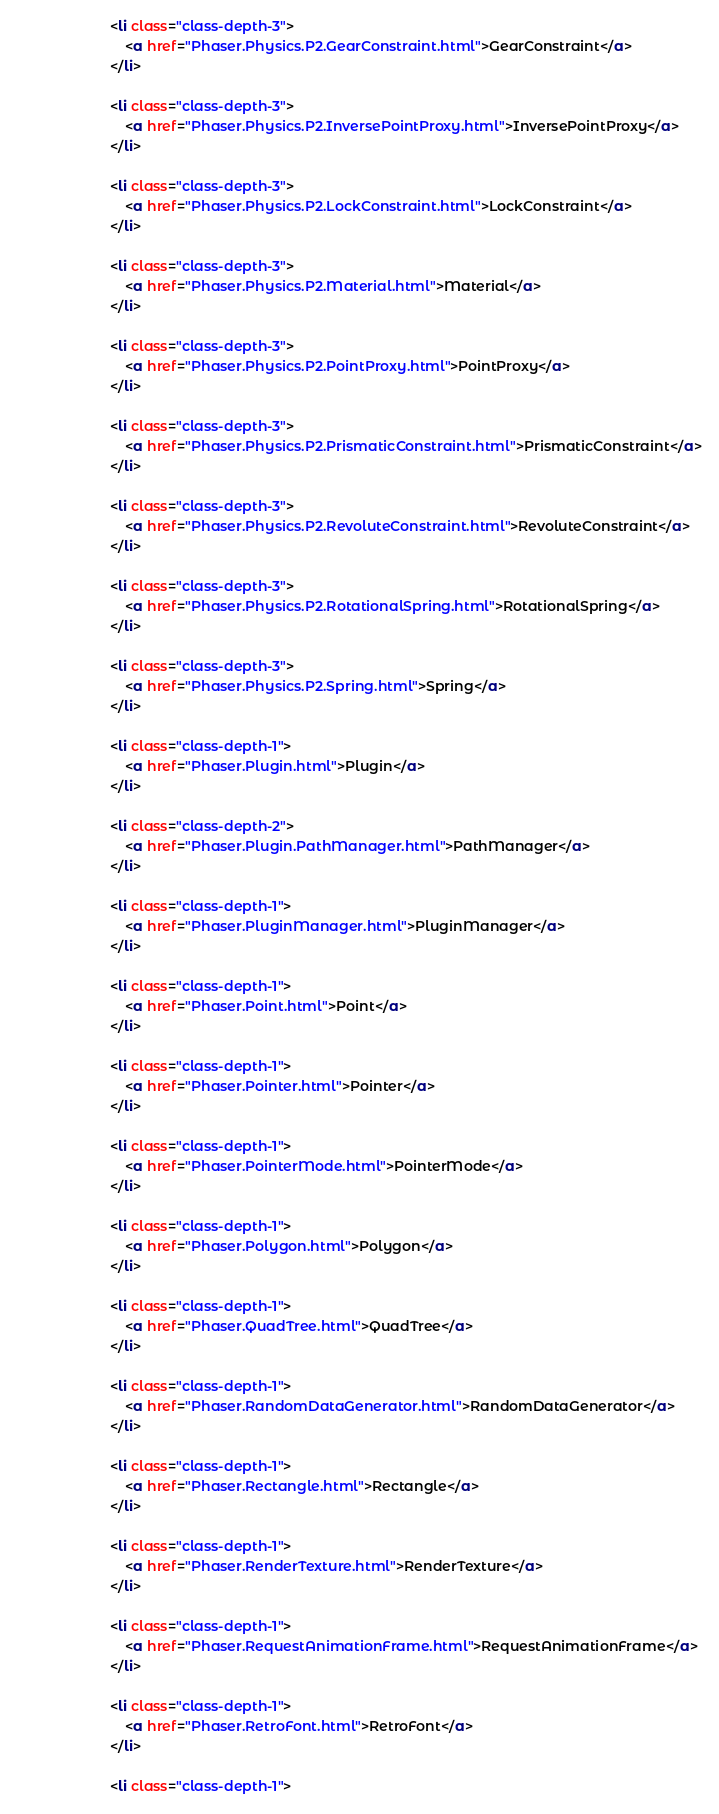Convert code to text. <code><loc_0><loc_0><loc_500><loc_500><_HTML_>						<li class="class-depth-3">
							<a href="Phaser.Physics.P2.GearConstraint.html">GearConstraint</a>
						</li>
						
						<li class="class-depth-3">
							<a href="Phaser.Physics.P2.InversePointProxy.html">InversePointProxy</a>
						</li>
						
						<li class="class-depth-3">
							<a href="Phaser.Physics.P2.LockConstraint.html">LockConstraint</a>
						</li>
						
						<li class="class-depth-3">
							<a href="Phaser.Physics.P2.Material.html">Material</a>
						</li>
						
						<li class="class-depth-3">
							<a href="Phaser.Physics.P2.PointProxy.html">PointProxy</a>
						</li>
						
						<li class="class-depth-3">
							<a href="Phaser.Physics.P2.PrismaticConstraint.html">PrismaticConstraint</a>
						</li>
						
						<li class="class-depth-3">
							<a href="Phaser.Physics.P2.RevoluteConstraint.html">RevoluteConstraint</a>
						</li>
						
						<li class="class-depth-3">
							<a href="Phaser.Physics.P2.RotationalSpring.html">RotationalSpring</a>
						</li>
						
						<li class="class-depth-3">
							<a href="Phaser.Physics.P2.Spring.html">Spring</a>
						</li>
						
						<li class="class-depth-1">
							<a href="Phaser.Plugin.html">Plugin</a>
						</li>
						
						<li class="class-depth-2">
							<a href="Phaser.Plugin.PathManager.html">PathManager</a>
						</li>
						
						<li class="class-depth-1">
							<a href="Phaser.PluginManager.html">PluginManager</a>
						</li>
						
						<li class="class-depth-1">
							<a href="Phaser.Point.html">Point</a>
						</li>
						
						<li class="class-depth-1">
							<a href="Phaser.Pointer.html">Pointer</a>
						</li>
						
						<li class="class-depth-1">
							<a href="Phaser.PointerMode.html">PointerMode</a>
						</li>
						
						<li class="class-depth-1">
							<a href="Phaser.Polygon.html">Polygon</a>
						</li>
						
						<li class="class-depth-1">
							<a href="Phaser.QuadTree.html">QuadTree</a>
						</li>
						
						<li class="class-depth-1">
							<a href="Phaser.RandomDataGenerator.html">RandomDataGenerator</a>
						</li>
						
						<li class="class-depth-1">
							<a href="Phaser.Rectangle.html">Rectangle</a>
						</li>
						
						<li class="class-depth-1">
							<a href="Phaser.RenderTexture.html">RenderTexture</a>
						</li>
						
						<li class="class-depth-1">
							<a href="Phaser.RequestAnimationFrame.html">RequestAnimationFrame</a>
						</li>
						
						<li class="class-depth-1">
							<a href="Phaser.RetroFont.html">RetroFont</a>
						</li>
						
						<li class="class-depth-1"></code> 